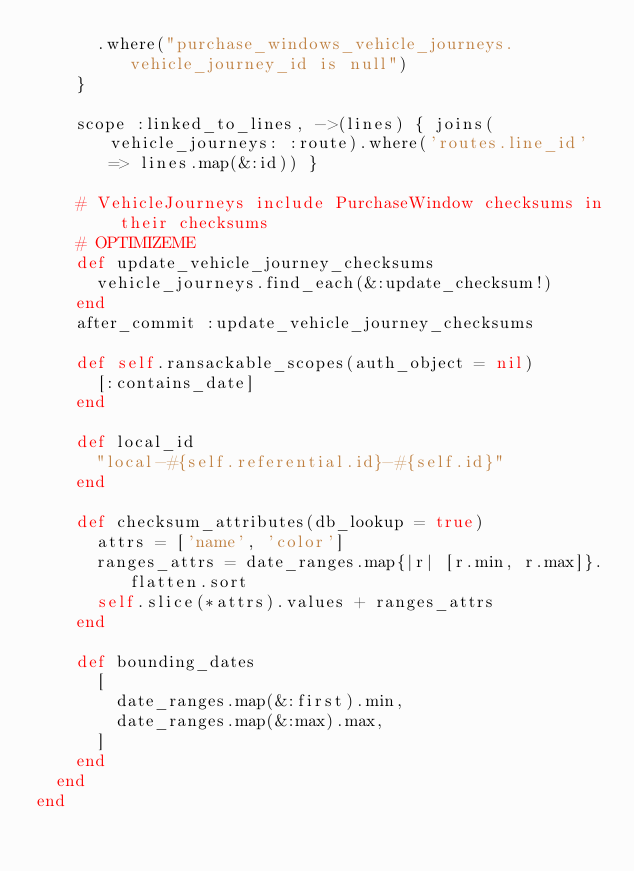<code> <loc_0><loc_0><loc_500><loc_500><_Ruby_>      .where("purchase_windows_vehicle_journeys.vehicle_journey_id is null")
    }

    scope :linked_to_lines, ->(lines) { joins(vehicle_journeys: :route).where('routes.line_id' => lines.map(&:id)) }

    # VehicleJourneys include PurchaseWindow checksums in their checksums
    # OPTIMIZEME
    def update_vehicle_journey_checksums
      vehicle_journeys.find_each(&:update_checksum!)
    end
    after_commit :update_vehicle_journey_checksums

    def self.ransackable_scopes(auth_object = nil)
      [:contains_date]
    end

    def local_id
      "local-#{self.referential.id}-#{self.id}"
    end

    def checksum_attributes(db_lookup = true)
      attrs = ['name', 'color']
      ranges_attrs = date_ranges.map{|r| [r.min, r.max]}.flatten.sort
      self.slice(*attrs).values + ranges_attrs
    end

    def bounding_dates
      [
        date_ranges.map(&:first).min,
        date_ranges.map(&:max).max,
      ]
    end
  end
end
</code> 